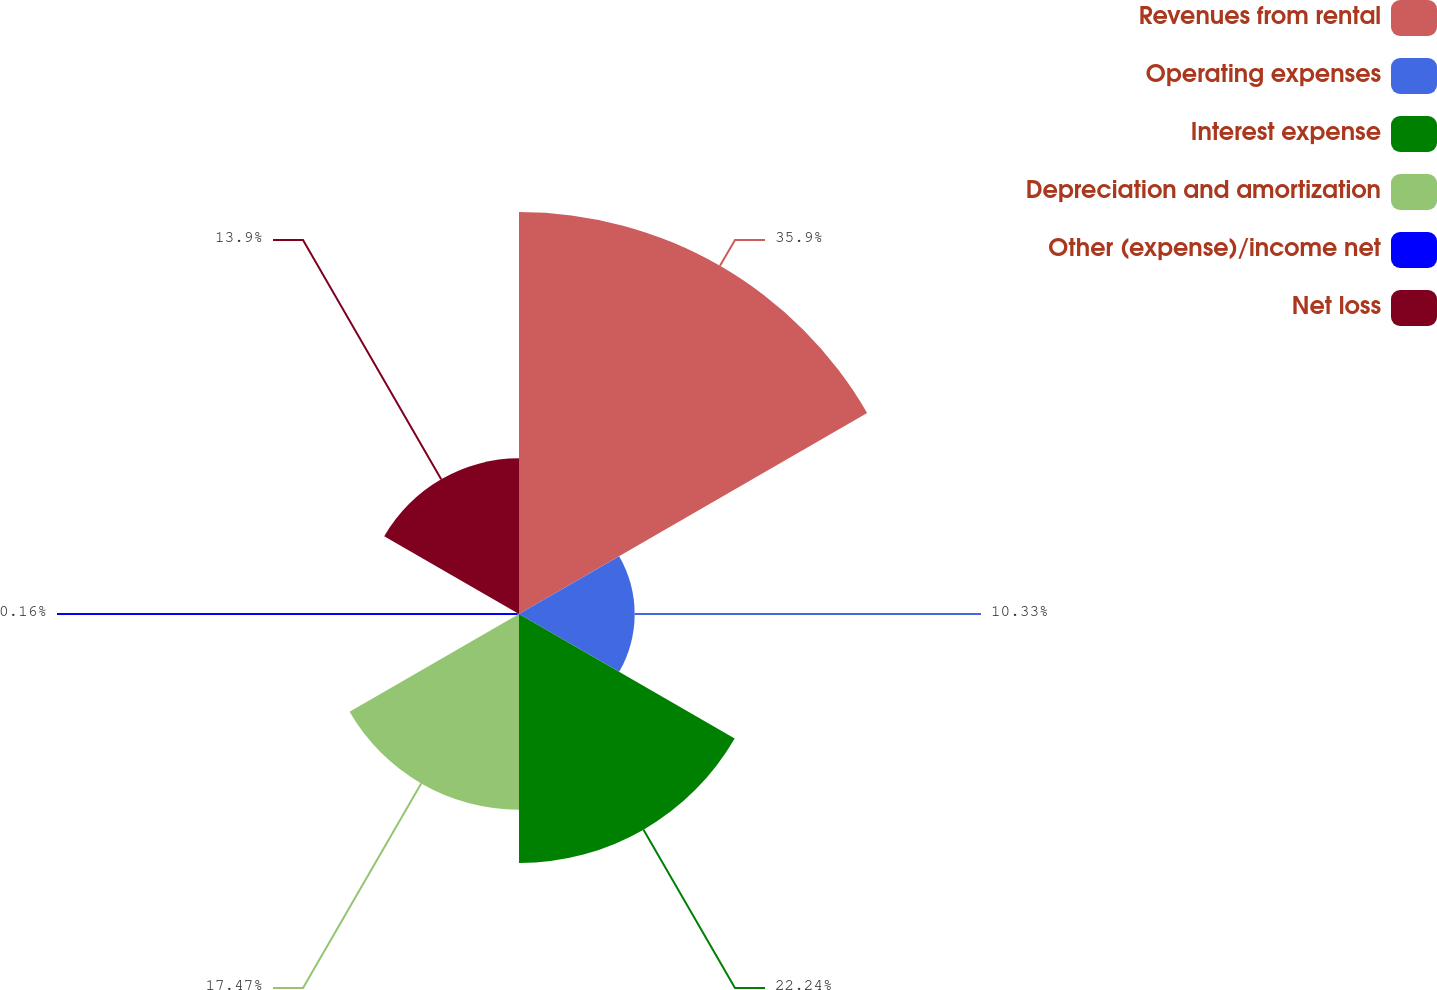Convert chart to OTSL. <chart><loc_0><loc_0><loc_500><loc_500><pie_chart><fcel>Revenues from rental<fcel>Operating expenses<fcel>Interest expense<fcel>Depreciation and amortization<fcel>Other (expense)/income net<fcel>Net loss<nl><fcel>35.9%<fcel>10.33%<fcel>22.24%<fcel>17.47%<fcel>0.16%<fcel>13.9%<nl></chart> 